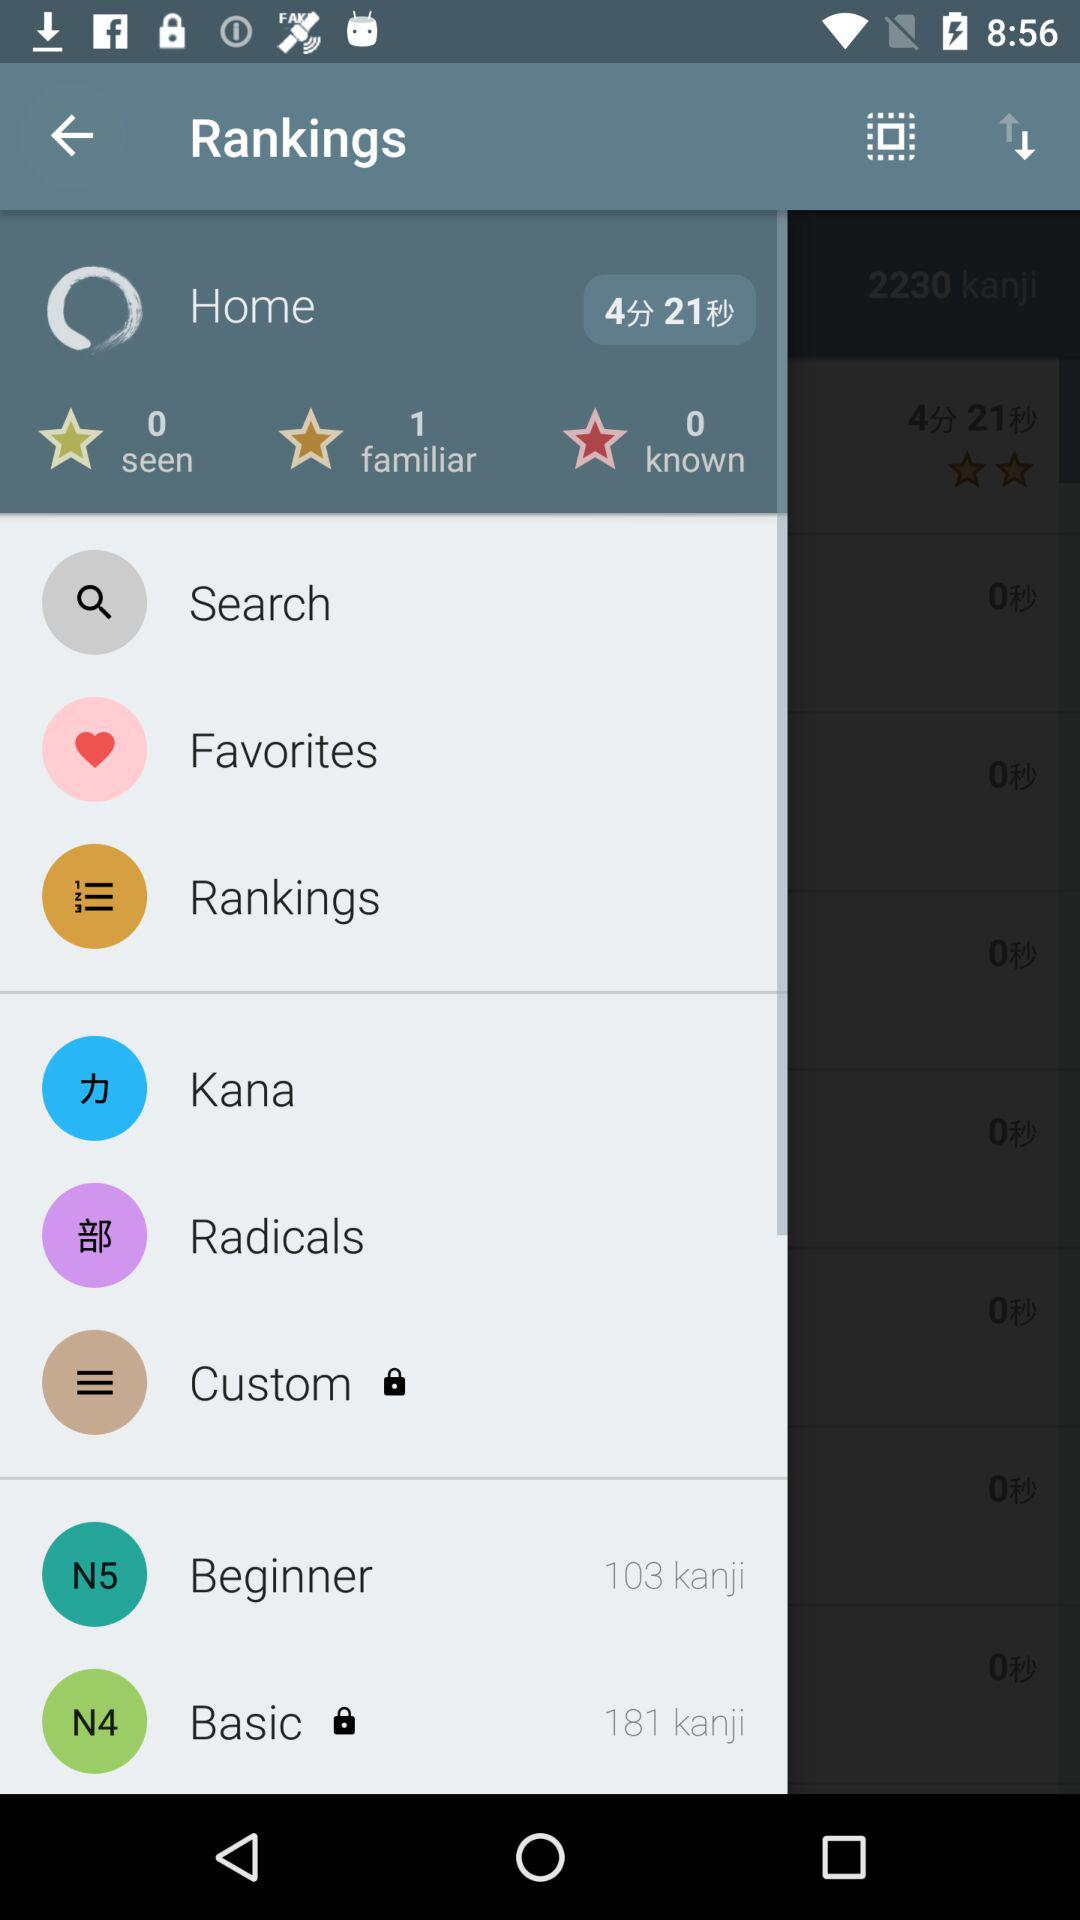What is the familiar count? The familiar count is 1. 